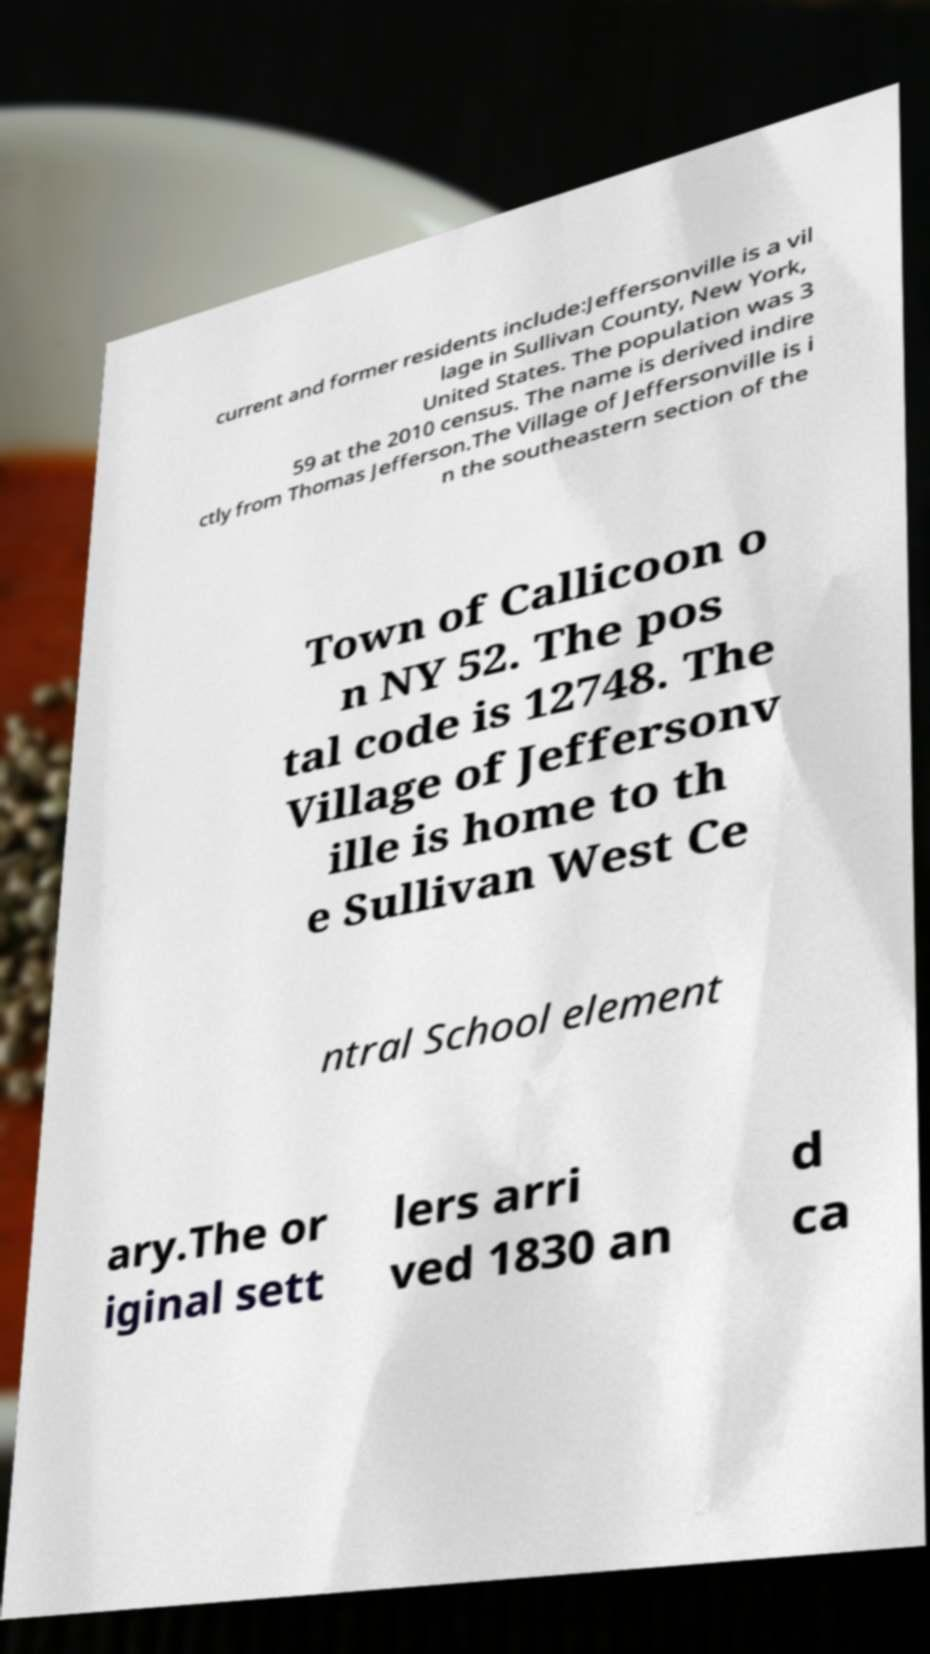Please read and relay the text visible in this image. What does it say? current and former residents include:Jeffersonville is a vil lage in Sullivan County, New York, United States. The population was 3 59 at the 2010 census. The name is derived indire ctly from Thomas Jefferson.The Village of Jeffersonville is i n the southeastern section of the Town of Callicoon o n NY 52. The pos tal code is 12748. The Village of Jeffersonv ille is home to th e Sullivan West Ce ntral School element ary.The or iginal sett lers arri ved 1830 an d ca 